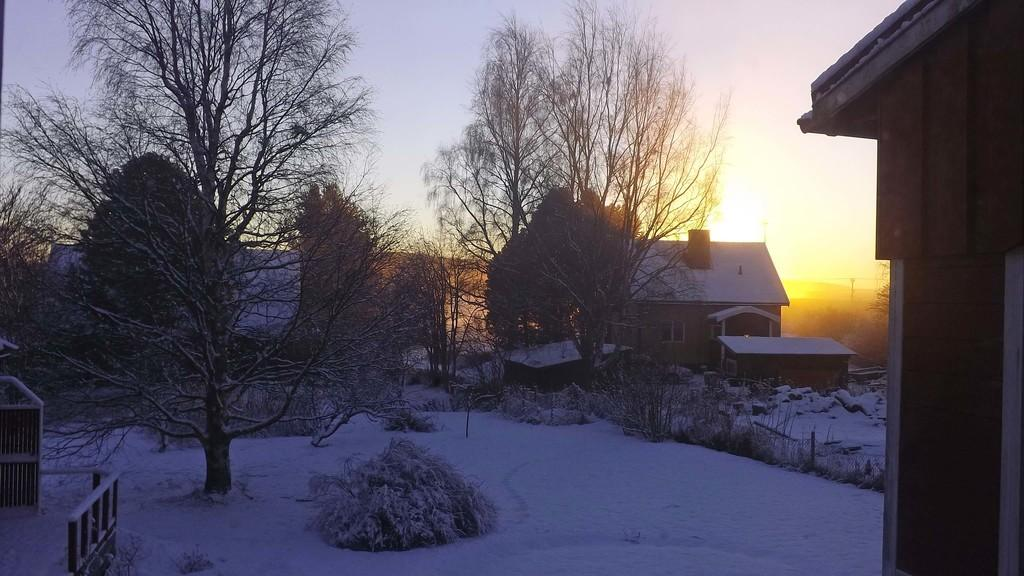What type of structures can be seen in the image? There are houses in the image. What feature is visible on the houses? There are windows visible on the houses. What type of vegetation is present in the image? There are trees in the image. What else can be seen in the image besides houses and trees? There are objects in the image. What is the weather like in the image? There is snow in the image, indicating a cold or wintry weather. What is visible at the top of the image? The sky is visible in the image. How many clocks are hanging on the trees in the image? There are no clocks visible on the trees in the image. In which direction is the north pole located in the image? The north pole is not a visible feature in the image, and its direction cannot be determined. 